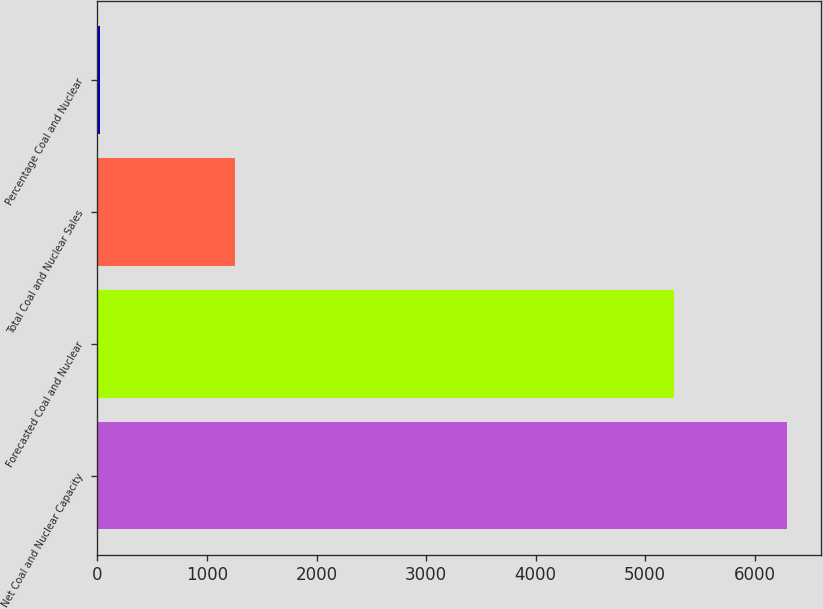Convert chart. <chart><loc_0><loc_0><loc_500><loc_500><bar_chart><fcel>Net Coal and Nuclear Capacity<fcel>Forecasted Coal and Nuclear<fcel>Total Coal and Nuclear Sales<fcel>Percentage Coal and Nuclear<nl><fcel>6290<fcel>5261<fcel>1251<fcel>24<nl></chart> 